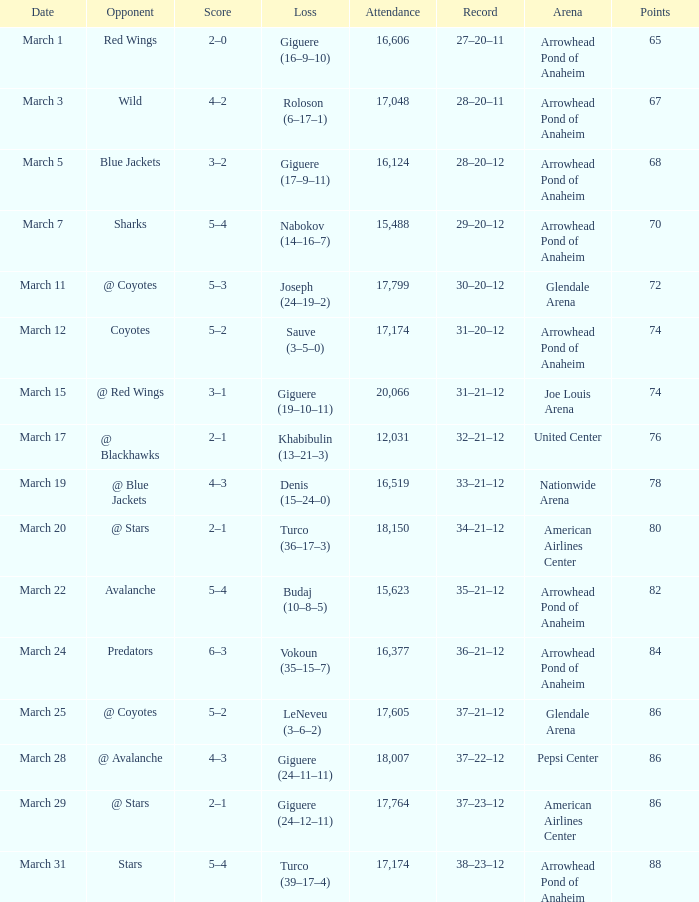What is the Attendance of the game with a Record of 37–21–12 and less than 86 Points? None. 